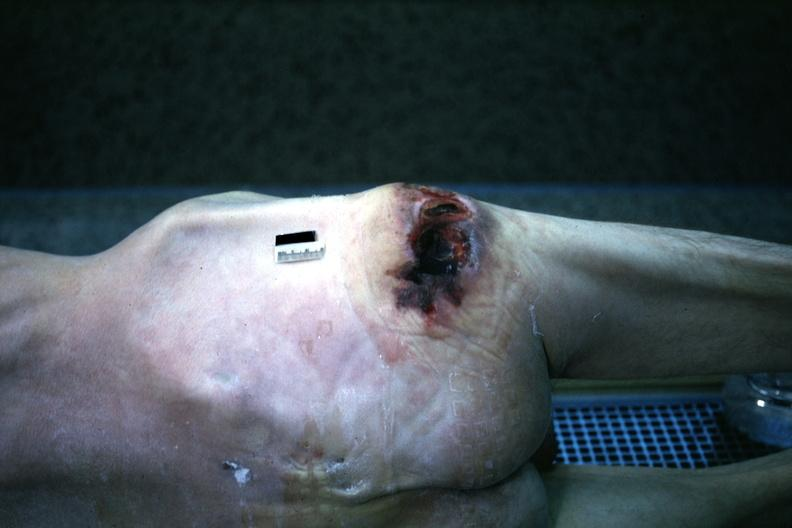where is this?
Answer the question using a single word or phrase. Skin 